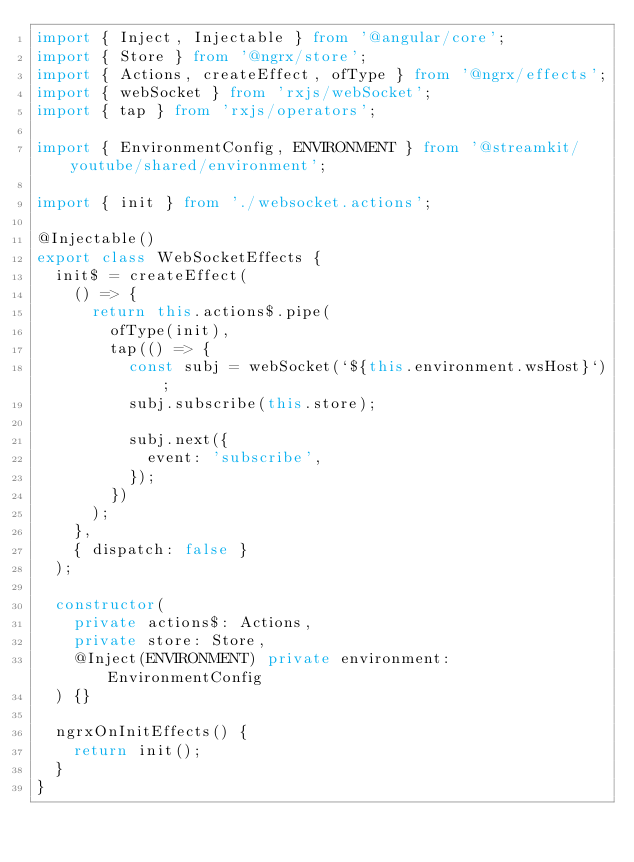Convert code to text. <code><loc_0><loc_0><loc_500><loc_500><_TypeScript_>import { Inject, Injectable } from '@angular/core';
import { Store } from '@ngrx/store';
import { Actions, createEffect, ofType } from '@ngrx/effects';
import { webSocket } from 'rxjs/webSocket';
import { tap } from 'rxjs/operators';

import { EnvironmentConfig, ENVIRONMENT } from '@streamkit/youtube/shared/environment';

import { init } from './websocket.actions';

@Injectable()
export class WebSocketEffects {
  init$ = createEffect(
    () => {
      return this.actions$.pipe(
        ofType(init),
        tap(() => {
          const subj = webSocket(`${this.environment.wsHost}`);
          subj.subscribe(this.store);

          subj.next({
            event: 'subscribe',
          });
        })
      );
    },
    { dispatch: false }
  );

  constructor(
    private actions$: Actions,
    private store: Store,
    @Inject(ENVIRONMENT) private environment: EnvironmentConfig 
  ) {}

  ngrxOnInitEffects() {
    return init();
  }
}
</code> 